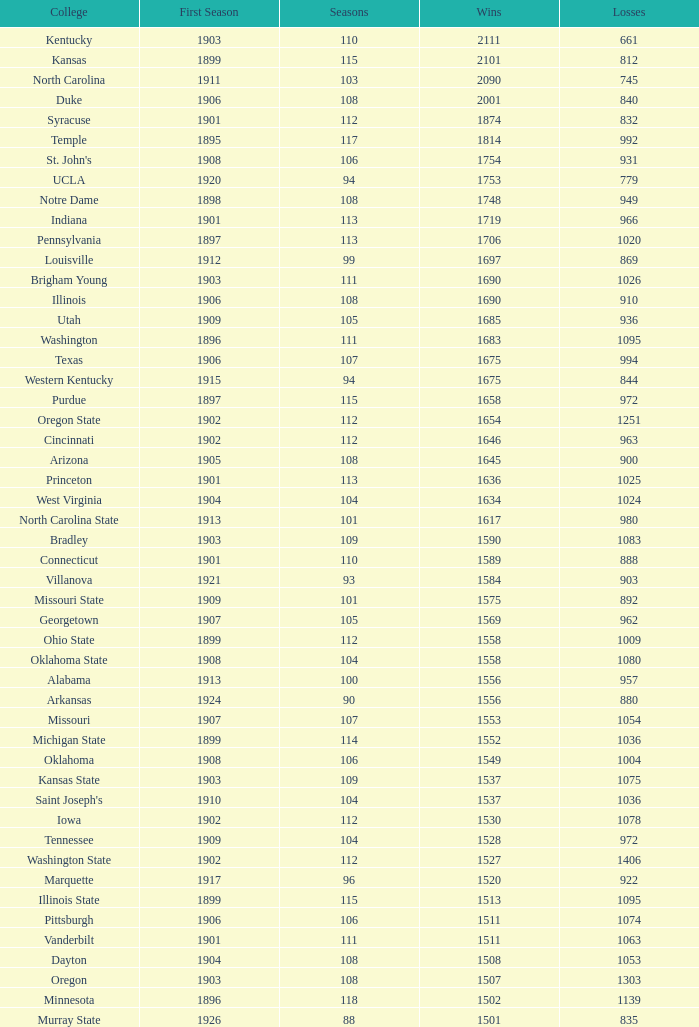What is the aggregate number of first season games featuring 1537 wins and a season above 109? None. 